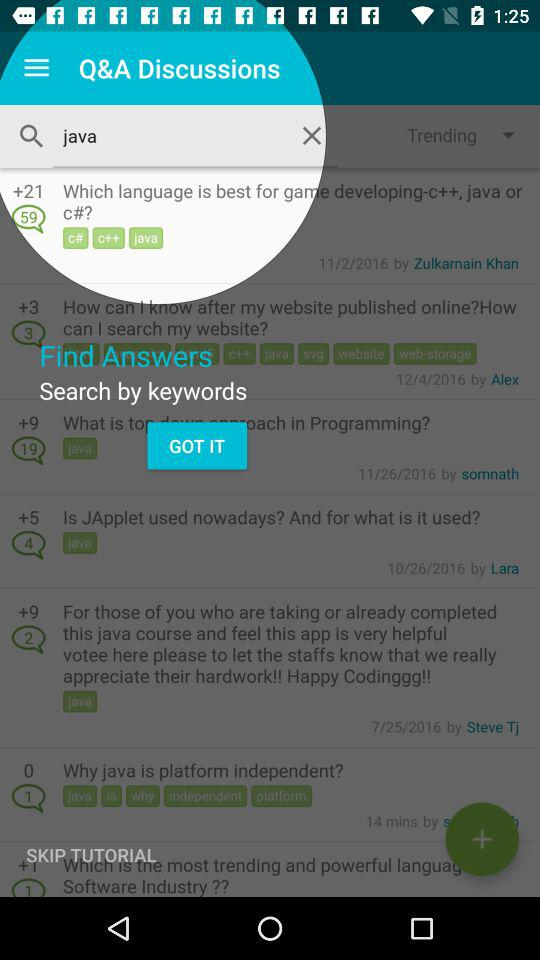How many chats are there?
When the provided information is insufficient, respond with <no answer>. <no answer> 